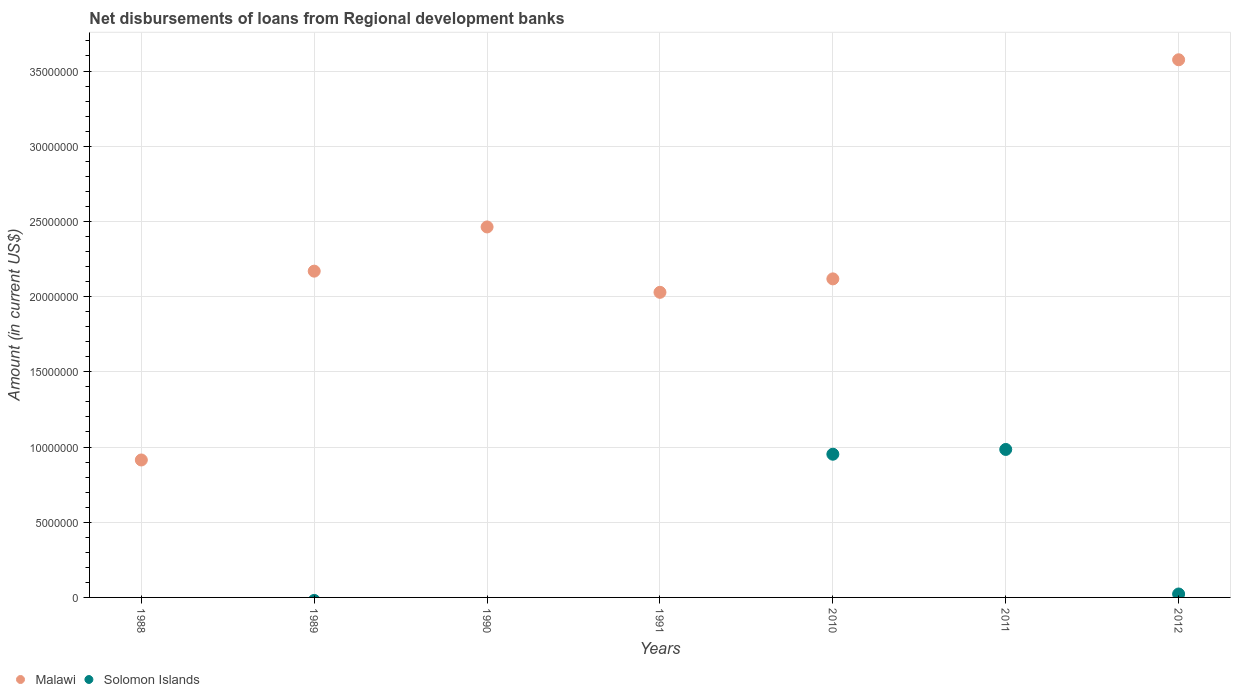What is the amount of disbursements of loans from regional development banks in Solomon Islands in 2012?
Give a very brief answer. 2.28e+05. Across all years, what is the maximum amount of disbursements of loans from regional development banks in Solomon Islands?
Your answer should be compact. 9.84e+06. What is the total amount of disbursements of loans from regional development banks in Solomon Islands in the graph?
Provide a short and direct response. 1.96e+07. What is the difference between the amount of disbursements of loans from regional development banks in Malawi in 1991 and that in 2010?
Your response must be concise. -8.94e+05. What is the difference between the amount of disbursements of loans from regional development banks in Malawi in 1988 and the amount of disbursements of loans from regional development banks in Solomon Islands in 2012?
Make the answer very short. 8.91e+06. What is the average amount of disbursements of loans from regional development banks in Solomon Islands per year?
Offer a terse response. 2.80e+06. In the year 2012, what is the difference between the amount of disbursements of loans from regional development banks in Solomon Islands and amount of disbursements of loans from regional development banks in Malawi?
Offer a terse response. -3.55e+07. What is the ratio of the amount of disbursements of loans from regional development banks in Solomon Islands in 2010 to that in 2011?
Your answer should be compact. 0.97. Is the amount of disbursements of loans from regional development banks in Malawi in 1989 less than that in 1990?
Give a very brief answer. Yes. What is the difference between the highest and the second highest amount of disbursements of loans from regional development banks in Malawi?
Provide a succinct answer. 1.11e+07. What is the difference between the highest and the lowest amount of disbursements of loans from regional development banks in Malawi?
Offer a terse response. 3.57e+07. In how many years, is the amount of disbursements of loans from regional development banks in Malawi greater than the average amount of disbursements of loans from regional development banks in Malawi taken over all years?
Give a very brief answer. 5. Is the sum of the amount of disbursements of loans from regional development banks in Malawi in 1989 and 1991 greater than the maximum amount of disbursements of loans from regional development banks in Solomon Islands across all years?
Give a very brief answer. Yes. Does the graph contain any zero values?
Your answer should be compact. Yes. How are the legend labels stacked?
Give a very brief answer. Horizontal. What is the title of the graph?
Make the answer very short. Net disbursements of loans from Regional development banks. What is the label or title of the Y-axis?
Keep it short and to the point. Amount (in current US$). What is the Amount (in current US$) in Malawi in 1988?
Provide a short and direct response. 9.14e+06. What is the Amount (in current US$) of Malawi in 1989?
Make the answer very short. 2.17e+07. What is the Amount (in current US$) in Malawi in 1990?
Make the answer very short. 2.46e+07. What is the Amount (in current US$) of Solomon Islands in 1990?
Make the answer very short. 0. What is the Amount (in current US$) in Malawi in 1991?
Offer a terse response. 2.03e+07. What is the Amount (in current US$) in Malawi in 2010?
Your response must be concise. 2.12e+07. What is the Amount (in current US$) of Solomon Islands in 2010?
Keep it short and to the point. 9.52e+06. What is the Amount (in current US$) of Solomon Islands in 2011?
Your response must be concise. 9.84e+06. What is the Amount (in current US$) of Malawi in 2012?
Offer a terse response. 3.57e+07. What is the Amount (in current US$) of Solomon Islands in 2012?
Provide a short and direct response. 2.28e+05. Across all years, what is the maximum Amount (in current US$) of Malawi?
Provide a short and direct response. 3.57e+07. Across all years, what is the maximum Amount (in current US$) in Solomon Islands?
Offer a terse response. 9.84e+06. Across all years, what is the minimum Amount (in current US$) of Solomon Islands?
Offer a very short reply. 0. What is the total Amount (in current US$) in Malawi in the graph?
Give a very brief answer. 1.33e+08. What is the total Amount (in current US$) in Solomon Islands in the graph?
Make the answer very short. 1.96e+07. What is the difference between the Amount (in current US$) in Malawi in 1988 and that in 1989?
Give a very brief answer. -1.26e+07. What is the difference between the Amount (in current US$) in Malawi in 1988 and that in 1990?
Your answer should be compact. -1.55e+07. What is the difference between the Amount (in current US$) in Malawi in 1988 and that in 1991?
Provide a short and direct response. -1.11e+07. What is the difference between the Amount (in current US$) in Malawi in 1988 and that in 2010?
Offer a terse response. -1.20e+07. What is the difference between the Amount (in current US$) in Malawi in 1988 and that in 2012?
Give a very brief answer. -2.66e+07. What is the difference between the Amount (in current US$) in Malawi in 1989 and that in 1990?
Make the answer very short. -2.94e+06. What is the difference between the Amount (in current US$) of Malawi in 1989 and that in 1991?
Provide a succinct answer. 1.41e+06. What is the difference between the Amount (in current US$) of Malawi in 1989 and that in 2010?
Make the answer very short. 5.14e+05. What is the difference between the Amount (in current US$) in Malawi in 1989 and that in 2012?
Keep it short and to the point. -1.41e+07. What is the difference between the Amount (in current US$) in Malawi in 1990 and that in 1991?
Provide a succinct answer. 4.35e+06. What is the difference between the Amount (in current US$) in Malawi in 1990 and that in 2010?
Ensure brevity in your answer.  3.45e+06. What is the difference between the Amount (in current US$) of Malawi in 1990 and that in 2012?
Provide a succinct answer. -1.11e+07. What is the difference between the Amount (in current US$) of Malawi in 1991 and that in 2010?
Offer a terse response. -8.94e+05. What is the difference between the Amount (in current US$) of Malawi in 1991 and that in 2012?
Make the answer very short. -1.55e+07. What is the difference between the Amount (in current US$) in Solomon Islands in 2010 and that in 2011?
Your answer should be compact. -3.17e+05. What is the difference between the Amount (in current US$) in Malawi in 2010 and that in 2012?
Make the answer very short. -1.46e+07. What is the difference between the Amount (in current US$) in Solomon Islands in 2010 and that in 2012?
Keep it short and to the point. 9.29e+06. What is the difference between the Amount (in current US$) of Solomon Islands in 2011 and that in 2012?
Keep it short and to the point. 9.61e+06. What is the difference between the Amount (in current US$) in Malawi in 1988 and the Amount (in current US$) in Solomon Islands in 2010?
Offer a very short reply. -3.83e+05. What is the difference between the Amount (in current US$) of Malawi in 1988 and the Amount (in current US$) of Solomon Islands in 2011?
Your response must be concise. -7.00e+05. What is the difference between the Amount (in current US$) in Malawi in 1988 and the Amount (in current US$) in Solomon Islands in 2012?
Make the answer very short. 8.91e+06. What is the difference between the Amount (in current US$) of Malawi in 1989 and the Amount (in current US$) of Solomon Islands in 2010?
Your answer should be very brief. 1.22e+07. What is the difference between the Amount (in current US$) in Malawi in 1989 and the Amount (in current US$) in Solomon Islands in 2011?
Make the answer very short. 1.19e+07. What is the difference between the Amount (in current US$) of Malawi in 1989 and the Amount (in current US$) of Solomon Islands in 2012?
Offer a very short reply. 2.15e+07. What is the difference between the Amount (in current US$) in Malawi in 1990 and the Amount (in current US$) in Solomon Islands in 2010?
Provide a succinct answer. 1.51e+07. What is the difference between the Amount (in current US$) in Malawi in 1990 and the Amount (in current US$) in Solomon Islands in 2011?
Provide a short and direct response. 1.48e+07. What is the difference between the Amount (in current US$) of Malawi in 1990 and the Amount (in current US$) of Solomon Islands in 2012?
Provide a succinct answer. 2.44e+07. What is the difference between the Amount (in current US$) of Malawi in 1991 and the Amount (in current US$) of Solomon Islands in 2010?
Your answer should be compact. 1.08e+07. What is the difference between the Amount (in current US$) of Malawi in 1991 and the Amount (in current US$) of Solomon Islands in 2011?
Ensure brevity in your answer.  1.04e+07. What is the difference between the Amount (in current US$) of Malawi in 1991 and the Amount (in current US$) of Solomon Islands in 2012?
Make the answer very short. 2.01e+07. What is the difference between the Amount (in current US$) of Malawi in 2010 and the Amount (in current US$) of Solomon Islands in 2011?
Provide a succinct answer. 1.13e+07. What is the difference between the Amount (in current US$) of Malawi in 2010 and the Amount (in current US$) of Solomon Islands in 2012?
Your response must be concise. 2.10e+07. What is the average Amount (in current US$) of Malawi per year?
Your response must be concise. 1.90e+07. What is the average Amount (in current US$) of Solomon Islands per year?
Ensure brevity in your answer.  2.80e+06. In the year 2010, what is the difference between the Amount (in current US$) in Malawi and Amount (in current US$) in Solomon Islands?
Make the answer very short. 1.17e+07. In the year 2012, what is the difference between the Amount (in current US$) in Malawi and Amount (in current US$) in Solomon Islands?
Give a very brief answer. 3.55e+07. What is the ratio of the Amount (in current US$) in Malawi in 1988 to that in 1989?
Keep it short and to the point. 0.42. What is the ratio of the Amount (in current US$) of Malawi in 1988 to that in 1990?
Your response must be concise. 0.37. What is the ratio of the Amount (in current US$) of Malawi in 1988 to that in 1991?
Keep it short and to the point. 0.45. What is the ratio of the Amount (in current US$) of Malawi in 1988 to that in 2010?
Keep it short and to the point. 0.43. What is the ratio of the Amount (in current US$) in Malawi in 1988 to that in 2012?
Make the answer very short. 0.26. What is the ratio of the Amount (in current US$) of Malawi in 1989 to that in 1990?
Give a very brief answer. 0.88. What is the ratio of the Amount (in current US$) of Malawi in 1989 to that in 1991?
Your answer should be very brief. 1.07. What is the ratio of the Amount (in current US$) of Malawi in 1989 to that in 2010?
Give a very brief answer. 1.02. What is the ratio of the Amount (in current US$) in Malawi in 1989 to that in 2012?
Your response must be concise. 0.61. What is the ratio of the Amount (in current US$) in Malawi in 1990 to that in 1991?
Keep it short and to the point. 1.21. What is the ratio of the Amount (in current US$) in Malawi in 1990 to that in 2010?
Make the answer very short. 1.16. What is the ratio of the Amount (in current US$) of Malawi in 1990 to that in 2012?
Offer a very short reply. 0.69. What is the ratio of the Amount (in current US$) in Malawi in 1991 to that in 2010?
Offer a very short reply. 0.96. What is the ratio of the Amount (in current US$) in Malawi in 1991 to that in 2012?
Offer a very short reply. 0.57. What is the ratio of the Amount (in current US$) in Solomon Islands in 2010 to that in 2011?
Ensure brevity in your answer.  0.97. What is the ratio of the Amount (in current US$) of Malawi in 2010 to that in 2012?
Give a very brief answer. 0.59. What is the ratio of the Amount (in current US$) of Solomon Islands in 2010 to that in 2012?
Your response must be concise. 41.76. What is the ratio of the Amount (in current US$) in Solomon Islands in 2011 to that in 2012?
Provide a succinct answer. 43.15. What is the difference between the highest and the second highest Amount (in current US$) in Malawi?
Your answer should be compact. 1.11e+07. What is the difference between the highest and the second highest Amount (in current US$) in Solomon Islands?
Your response must be concise. 3.17e+05. What is the difference between the highest and the lowest Amount (in current US$) in Malawi?
Offer a terse response. 3.57e+07. What is the difference between the highest and the lowest Amount (in current US$) of Solomon Islands?
Your answer should be very brief. 9.84e+06. 